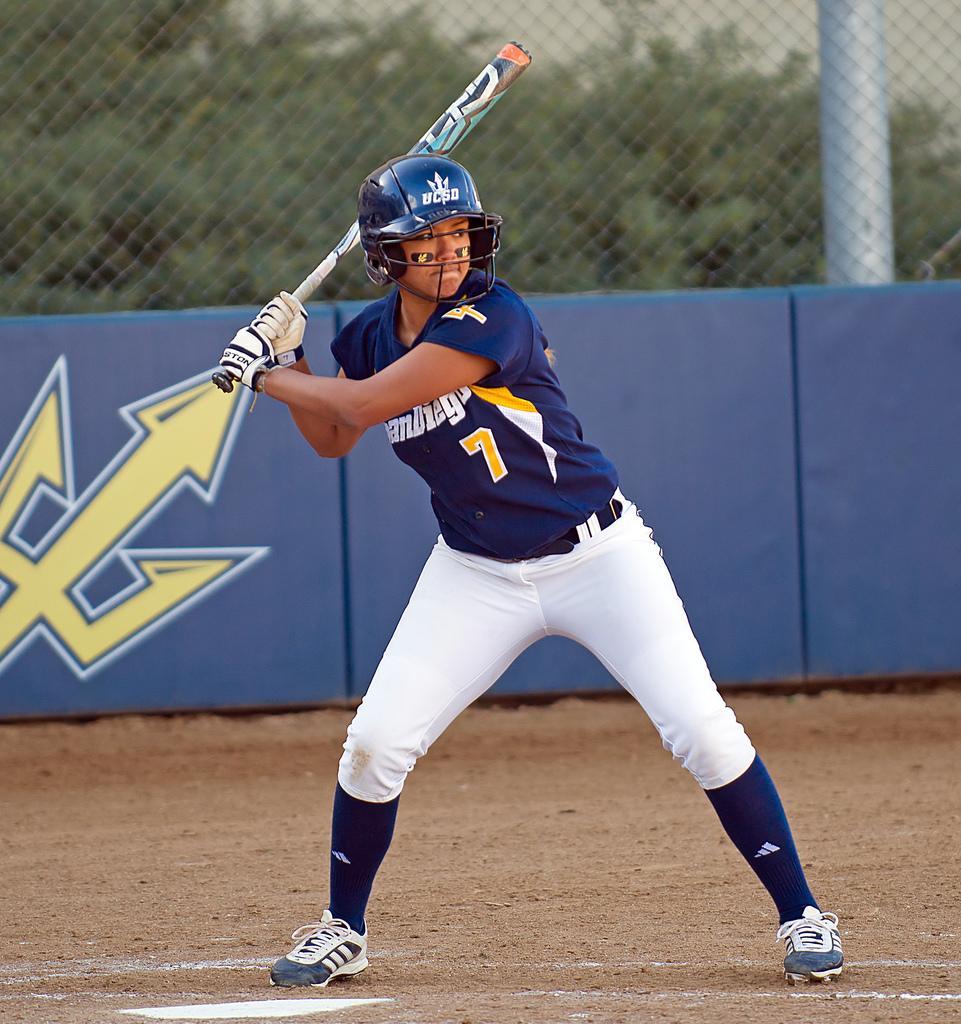In one or two sentences, can you explain what this image depicts? In this image we can see a person with sports uniform wearing a helmet and holding a baseball bat on the ground, in the background it looks like a banner with design, and there is a fence, an iron pole and trees 